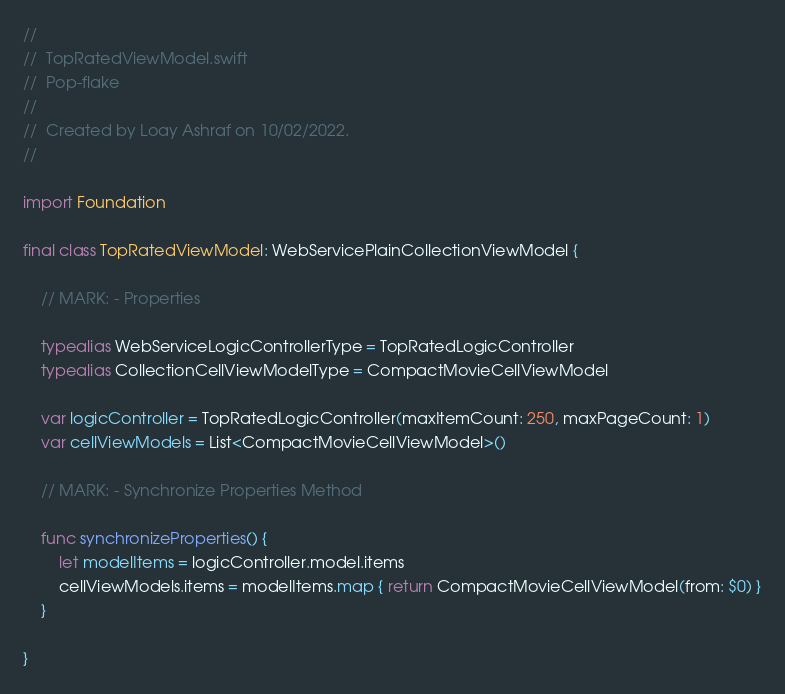Convert code to text. <code><loc_0><loc_0><loc_500><loc_500><_Swift_>//
//  TopRatedViewModel.swift
//  Pop-flake
//
//  Created by Loay Ashraf on 10/02/2022.
//

import Foundation

final class TopRatedViewModel: WebServicePlainCollectionViewModel {

    // MARK: - Properties
    
    typealias WebServiceLogicControllerType = TopRatedLogicController
    typealias CollectionCellViewModelType = CompactMovieCellViewModel
    
    var logicController = TopRatedLogicController(maxItemCount: 250, maxPageCount: 1)
    var cellViewModels = List<CompactMovieCellViewModel>()
    
    // MARK: - Synchronize Properties Method

    func synchronizeProperties() {
        let modelItems = logicController.model.items
        cellViewModels.items = modelItems.map { return CompactMovieCellViewModel(from: $0) }
    }

}
</code> 